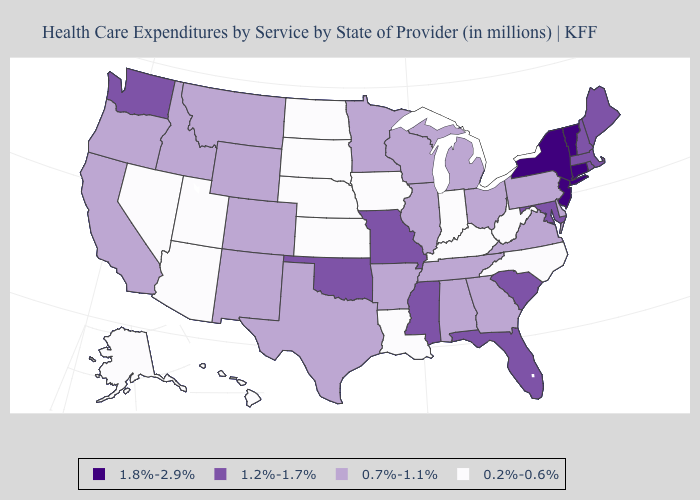Name the states that have a value in the range 0.2%-0.6%?
Be succinct. Alaska, Arizona, Hawaii, Indiana, Iowa, Kansas, Kentucky, Louisiana, Nebraska, Nevada, North Carolina, North Dakota, South Dakota, Utah, West Virginia. What is the lowest value in the West?
Short answer required. 0.2%-0.6%. What is the lowest value in the MidWest?
Short answer required. 0.2%-0.6%. What is the lowest value in the Northeast?
Short answer required. 0.7%-1.1%. Name the states that have a value in the range 0.7%-1.1%?
Give a very brief answer. Alabama, Arkansas, California, Colorado, Delaware, Georgia, Idaho, Illinois, Michigan, Minnesota, Montana, New Mexico, Ohio, Oregon, Pennsylvania, Tennessee, Texas, Virginia, Wisconsin, Wyoming. Does the map have missing data?
Quick response, please. No. What is the value of Alabama?
Answer briefly. 0.7%-1.1%. Does Michigan have the lowest value in the USA?
Answer briefly. No. Name the states that have a value in the range 1.8%-2.9%?
Give a very brief answer. Connecticut, New Jersey, New York, Vermont. Which states have the lowest value in the South?
Keep it brief. Kentucky, Louisiana, North Carolina, West Virginia. Does Illinois have a lower value than Washington?
Answer briefly. Yes. Among the states that border Iowa , which have the lowest value?
Give a very brief answer. Nebraska, South Dakota. What is the highest value in the West ?
Give a very brief answer. 1.2%-1.7%. Does Kentucky have a higher value than Delaware?
Write a very short answer. No. What is the value of Vermont?
Be succinct. 1.8%-2.9%. 